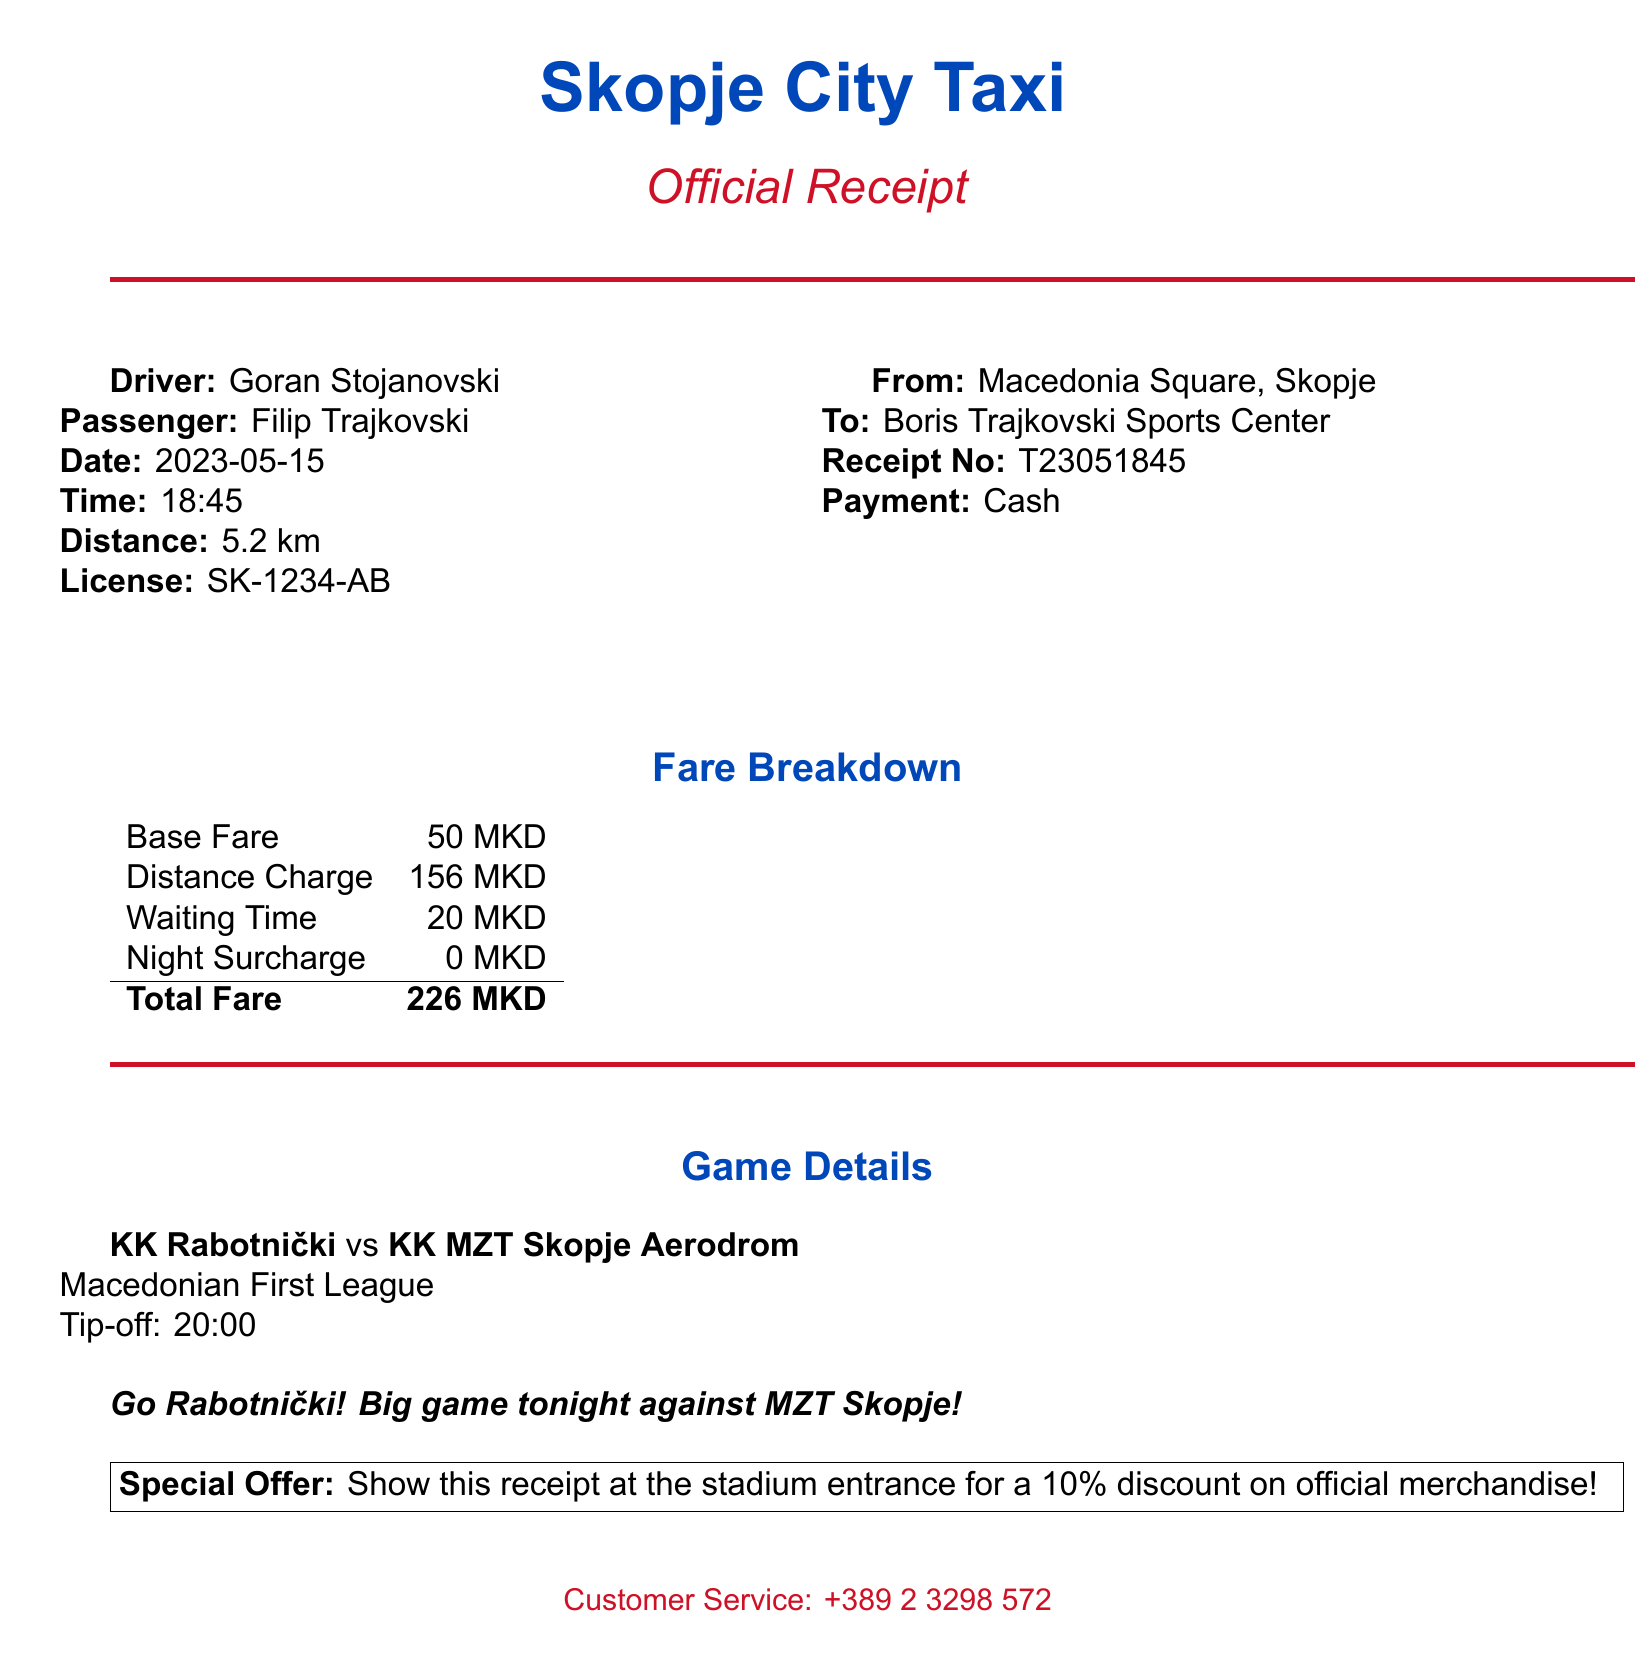What is the name of the taxi company? The taxi company is explicitly stated in the document as "Skopje City Taxi."
Answer: Skopje City Taxi Who is the driver? The document clearly identifies the driver as "Goran Stojanovski."
Answer: Goran Stojanovski What is the total fare? The total fare is listed in the fare breakdown section of the receipt as "226 MKD."
Answer: 226 MKD What is the pickup location? The document specifies the pickup location as "Macedonia Square, Skopje."
Answer: Macedonia Square, Skopje What is the distance traveled? The distance traveled is mentioned in the document as "5.2 km."
Answer: 5.2 km What game is being referred to in the receipt? The game details specify the match between "KK Rabotnički" and "KK MZT Skopje Aerodrom."
Answer: KK Rabotnički vs KK MZT Skopje Aerodrom What time does the game start? The start time for the game is clearly noted as "20:00."
Answer: 20:00 Is there a promotional offer mentioned? The receipt includes a specific offer that encourages showing the receipt for a discount, indicating it's a promotional offer.
Answer: Yes, 10% discount on official merchandise What method of payment was used? The payment method is outlined in the document as "Cash."
Answer: Cash What additional note is included in the receipt? The document includes an enthusiastic comment stating "Go Rabotnički! Big game tonight against MZT Skopje!"
Answer: Go Rabotnički! Big game tonight against MZT Skopje! 